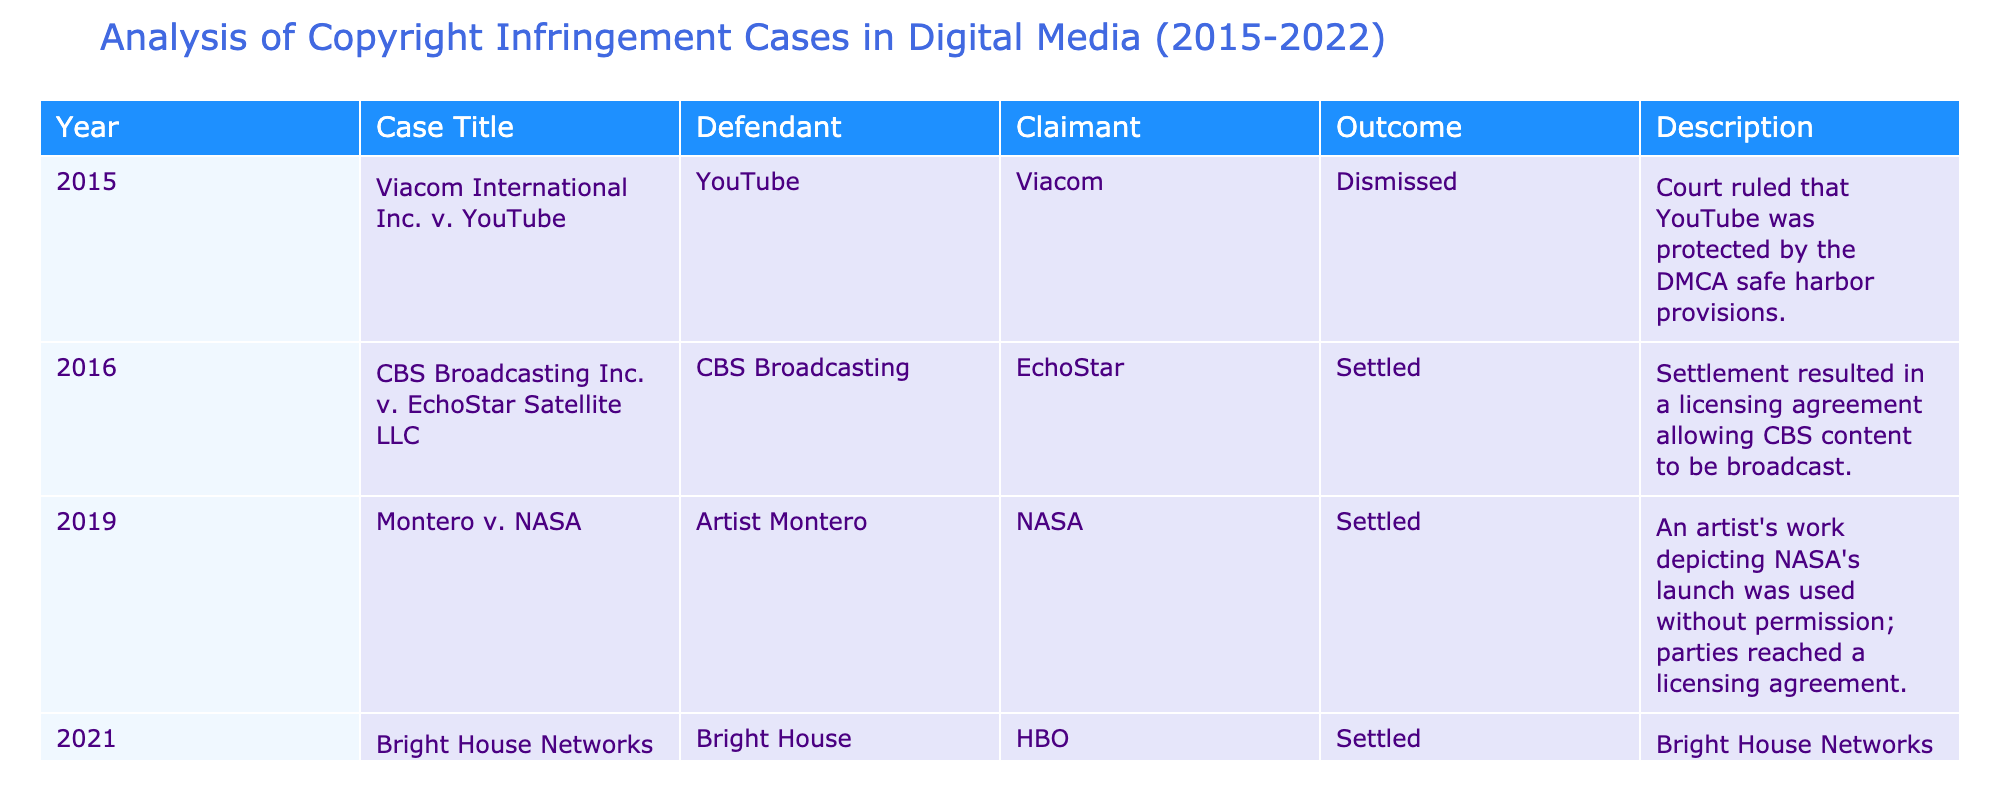What was the outcome of the Viacom International Inc. v. YouTube case? The outcome listed for this case is "Dismissed," which indicates that the court decided in favor of YouTube.
Answer: Dismissed How many cases were settled between 2015 and 2022? From the table, there are three cases marked as "Settled": the cases in 2016, 2019, and 2021. Adding them gives a total of three settled cases.
Answer: Three Which case involved NASA as a claimant? The case titled "Montero v. NASA" from 2019 involved NASA as the claimant.
Answer: Montero v. NASA Were there any cases where the claimants and defendants reached a settlement in 2021? Yes, the case "Bright House Networks v. HBO" in 2021 was settled, indicating that both parties reached an agreement.
Answer: Yes What percentage of the cases resulted in a dismissal? There are four cases total, and one case resulted in a dismissal (Viacom International Inc. v. YouTube). The percentage is calculated as (1/4) * 100 = 25%.
Answer: 25% Which year had the case with the most recent settlement, and what was its title? The most recent settlement occurred in 2021, titled "Bright House Networks v. HBO."
Answer: 2021, Bright House Networks v. HBO In how many cases was the DMCA safe harbor provisions referenced? Only one case references the DMCA safe harbor provisions, which is the case of Viacom International Inc. v. YouTube.
Answer: One Did any of the cases involve unauthorized use of content? Yes, both the Montero v. NASA and Bright House Networks v. HBO cases involved unauthorized use of content, as described in their summaries.
Answer: Yes What is the chronological order of the cases from 2015 to 2021 based on the table? The chronological order is: 2015 - Viacom International Inc. v. YouTube; 2016 - CBS Broadcasting Inc. v. EchoStar Satellite LLC; 2019 - Montero v. NASA; 2021 - Bright House Networks v. HBO.
Answer: Viacom International Inc. v. YouTube, CBS Broadcasting Inc. v. EchoStar Satellite LLC, Montero v. NASA, Bright House Networks v. HBO 